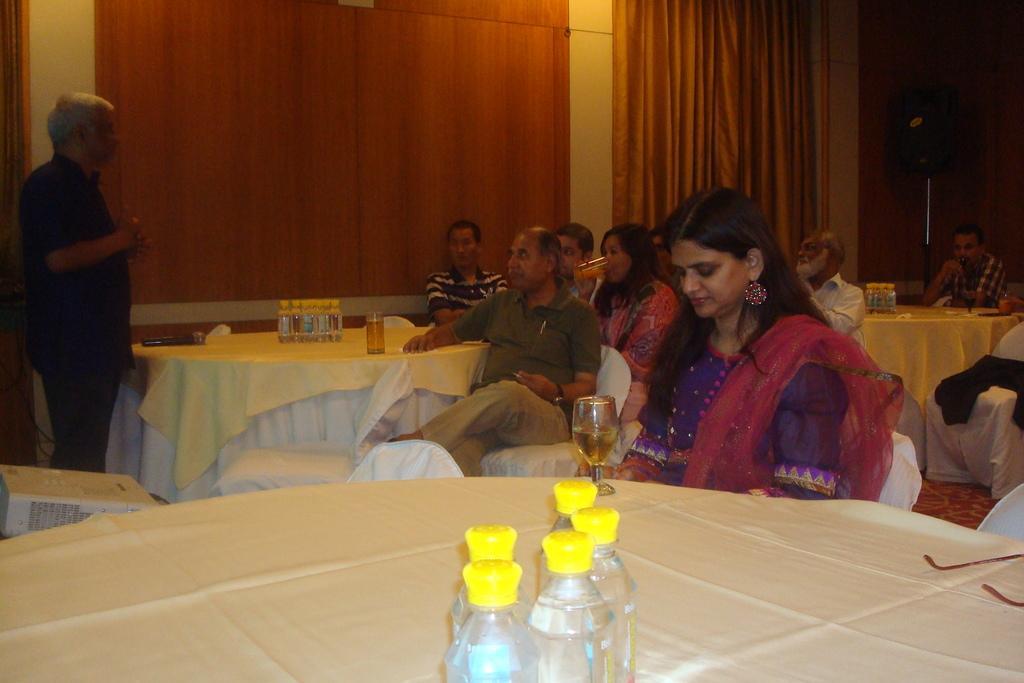Could you give a brief overview of what you see in this image? In this Image I see people, in which most of them are sitting on chairs and there is a man standing over here and I see there are tables in front of them on which there are bottles and glasses. I can also see this woman is holding a glass and I see a electronic device over here. In the background I see the wall and the curtain over here. 